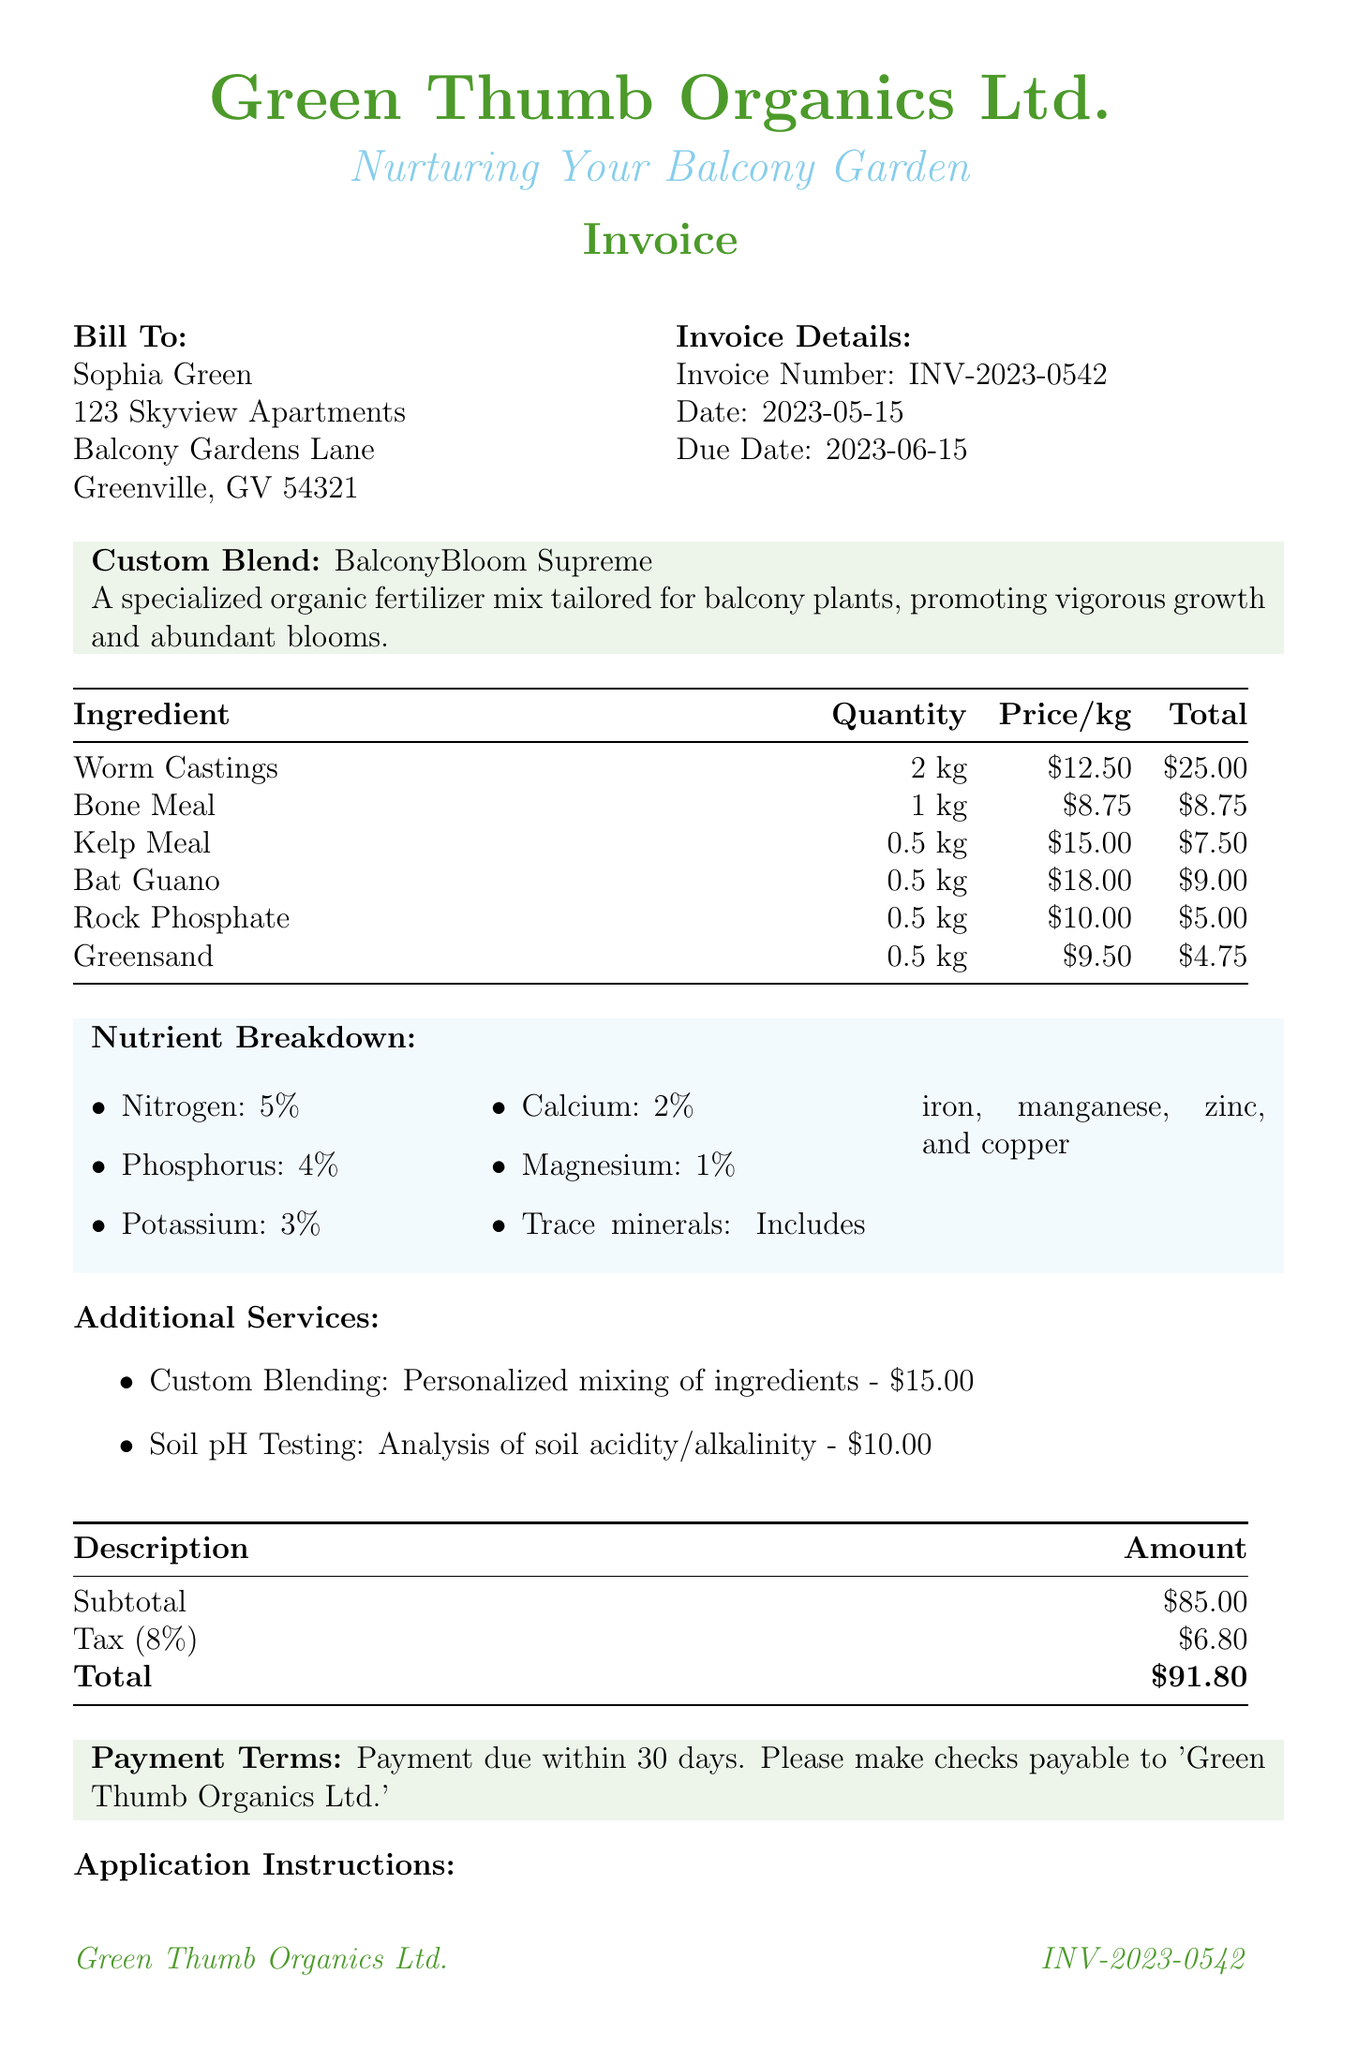What is the invoice number? The invoice number is explicitly stated in the document as INV-2023-0542.
Answer: INV-2023-0542 What is the name of the custom blend? The custom blend is named "BalconyBloom Supreme."
Answer: BalconyBloom Supreme How much does the Bat Guano cost per kilogram? The price per kilogram for Bat Guano is provided as $18.00.
Answer: $18.00 What is the total amount due? The total amount due is calculated as the sum of the subtotal and tax, which is $91.80.
Answer: $91.80 What percentage of nitrogen is in the nutrient breakdown? The nutrient breakdown specifies that nitrogen is at 5%.
Answer: 5% What is the application frequency for flowering plants? The document states that flowering plants should be fertilized every 4 weeks during blooming season.
Answer: every 4 weeks What additional service is offered for soil analysis? The invoice lists soil pH testing as the service offered for soil analysis.
Answer: Soil pH Testing What is the due date for the invoice? The due date for payment is explicitly mentioned as June 15, 2023.
Answer: 2023-06-15 What application instruction is given for herbs? The document specifies that herbs should receive 0.5 cups every 6 weeks.
Answer: 0.5 cups per plant every 6 weeks 